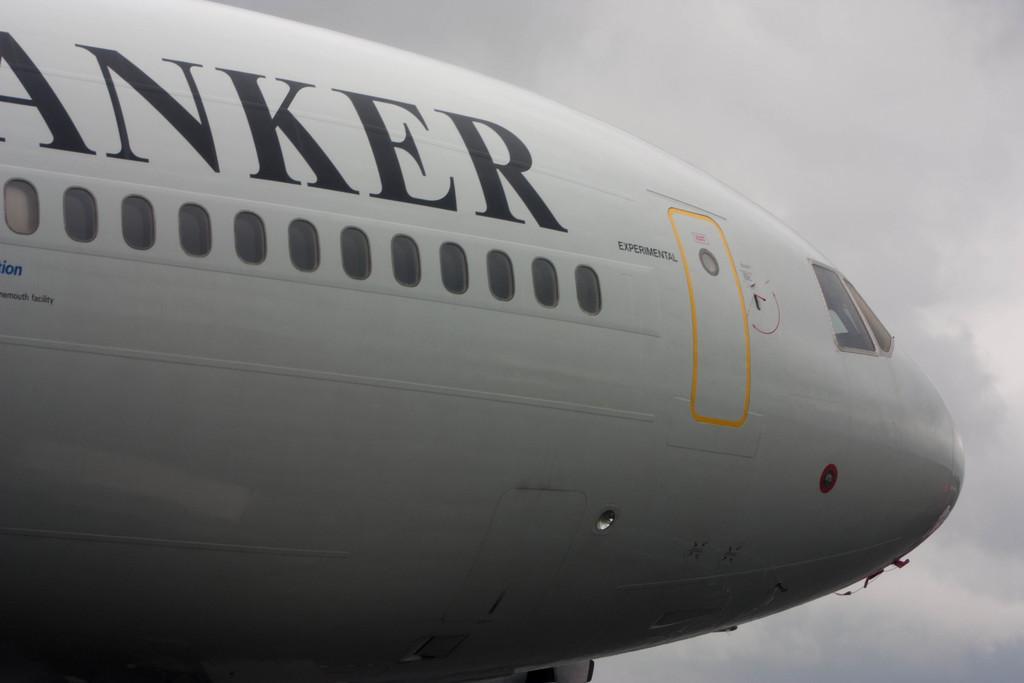Could you give a brief overview of what you see in this image? This picture shows an aeroplane, It is white in color. We see text on it and a cloudy sky 